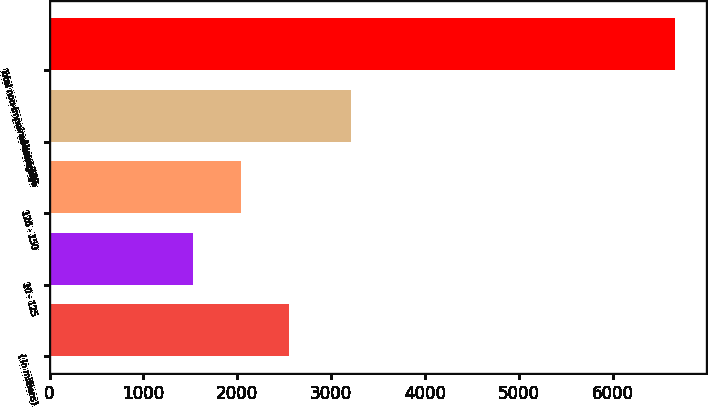Convert chart to OTSL. <chart><loc_0><loc_0><loc_500><loc_500><bar_chart><fcel>( in millions)<fcel>10 - 125<fcel>126 - 150<fcel>Above 150<fcel>Total non-impaired mortgage<nl><fcel>2553.4<fcel>1527<fcel>2040.2<fcel>3214<fcel>6659<nl></chart> 